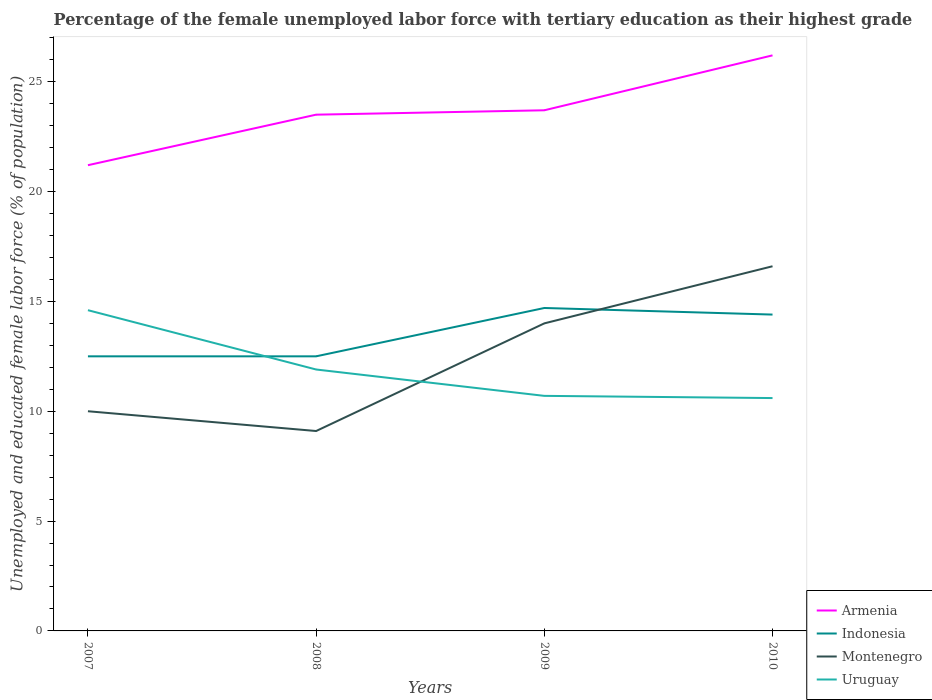Is the number of lines equal to the number of legend labels?
Ensure brevity in your answer.  Yes. Across all years, what is the maximum percentage of the unemployed female labor force with tertiary education in Montenegro?
Your answer should be compact. 9.1. In which year was the percentage of the unemployed female labor force with tertiary education in Montenegro maximum?
Provide a succinct answer. 2008. What is the total percentage of the unemployed female labor force with tertiary education in Uruguay in the graph?
Your response must be concise. 1.2. What is the difference between the highest and the second highest percentage of the unemployed female labor force with tertiary education in Indonesia?
Offer a very short reply. 2.2. What is the difference between the highest and the lowest percentage of the unemployed female labor force with tertiary education in Montenegro?
Ensure brevity in your answer.  2. Is the percentage of the unemployed female labor force with tertiary education in Montenegro strictly greater than the percentage of the unemployed female labor force with tertiary education in Indonesia over the years?
Give a very brief answer. No. What is the difference between two consecutive major ticks on the Y-axis?
Make the answer very short. 5. How many legend labels are there?
Offer a terse response. 4. How are the legend labels stacked?
Your answer should be compact. Vertical. What is the title of the graph?
Ensure brevity in your answer.  Percentage of the female unemployed labor force with tertiary education as their highest grade. What is the label or title of the X-axis?
Your response must be concise. Years. What is the label or title of the Y-axis?
Offer a terse response. Unemployed and educated female labor force (% of population). What is the Unemployed and educated female labor force (% of population) of Armenia in 2007?
Offer a very short reply. 21.2. What is the Unemployed and educated female labor force (% of population) of Indonesia in 2007?
Your answer should be compact. 12.5. What is the Unemployed and educated female labor force (% of population) in Uruguay in 2007?
Offer a very short reply. 14.6. What is the Unemployed and educated female labor force (% of population) of Indonesia in 2008?
Your answer should be very brief. 12.5. What is the Unemployed and educated female labor force (% of population) in Montenegro in 2008?
Provide a short and direct response. 9.1. What is the Unemployed and educated female labor force (% of population) of Uruguay in 2008?
Your response must be concise. 11.9. What is the Unemployed and educated female labor force (% of population) of Armenia in 2009?
Provide a succinct answer. 23.7. What is the Unemployed and educated female labor force (% of population) in Indonesia in 2009?
Give a very brief answer. 14.7. What is the Unemployed and educated female labor force (% of population) in Uruguay in 2009?
Provide a succinct answer. 10.7. What is the Unemployed and educated female labor force (% of population) of Armenia in 2010?
Your answer should be very brief. 26.2. What is the Unemployed and educated female labor force (% of population) of Indonesia in 2010?
Your response must be concise. 14.4. What is the Unemployed and educated female labor force (% of population) in Montenegro in 2010?
Keep it short and to the point. 16.6. What is the Unemployed and educated female labor force (% of population) in Uruguay in 2010?
Your response must be concise. 10.6. Across all years, what is the maximum Unemployed and educated female labor force (% of population) of Armenia?
Provide a short and direct response. 26.2. Across all years, what is the maximum Unemployed and educated female labor force (% of population) of Indonesia?
Provide a short and direct response. 14.7. Across all years, what is the maximum Unemployed and educated female labor force (% of population) of Montenegro?
Provide a short and direct response. 16.6. Across all years, what is the maximum Unemployed and educated female labor force (% of population) of Uruguay?
Offer a terse response. 14.6. Across all years, what is the minimum Unemployed and educated female labor force (% of population) in Armenia?
Offer a terse response. 21.2. Across all years, what is the minimum Unemployed and educated female labor force (% of population) of Indonesia?
Make the answer very short. 12.5. Across all years, what is the minimum Unemployed and educated female labor force (% of population) of Montenegro?
Offer a terse response. 9.1. Across all years, what is the minimum Unemployed and educated female labor force (% of population) of Uruguay?
Provide a succinct answer. 10.6. What is the total Unemployed and educated female labor force (% of population) of Armenia in the graph?
Make the answer very short. 94.6. What is the total Unemployed and educated female labor force (% of population) of Indonesia in the graph?
Make the answer very short. 54.1. What is the total Unemployed and educated female labor force (% of population) of Montenegro in the graph?
Provide a short and direct response. 49.7. What is the total Unemployed and educated female labor force (% of population) of Uruguay in the graph?
Offer a terse response. 47.8. What is the difference between the Unemployed and educated female labor force (% of population) in Armenia in 2007 and that in 2008?
Offer a terse response. -2.3. What is the difference between the Unemployed and educated female labor force (% of population) in Indonesia in 2007 and that in 2008?
Keep it short and to the point. 0. What is the difference between the Unemployed and educated female labor force (% of population) of Armenia in 2007 and that in 2009?
Your answer should be compact. -2.5. What is the difference between the Unemployed and educated female labor force (% of population) in Armenia in 2007 and that in 2010?
Offer a very short reply. -5. What is the difference between the Unemployed and educated female labor force (% of population) in Indonesia in 2007 and that in 2010?
Offer a very short reply. -1.9. What is the difference between the Unemployed and educated female labor force (% of population) in Montenegro in 2007 and that in 2010?
Ensure brevity in your answer.  -6.6. What is the difference between the Unemployed and educated female labor force (% of population) of Uruguay in 2007 and that in 2010?
Your answer should be compact. 4. What is the difference between the Unemployed and educated female labor force (% of population) of Montenegro in 2008 and that in 2009?
Provide a short and direct response. -4.9. What is the difference between the Unemployed and educated female labor force (% of population) of Armenia in 2008 and that in 2010?
Give a very brief answer. -2.7. What is the difference between the Unemployed and educated female labor force (% of population) of Indonesia in 2008 and that in 2010?
Provide a short and direct response. -1.9. What is the difference between the Unemployed and educated female labor force (% of population) of Armenia in 2007 and the Unemployed and educated female labor force (% of population) of Montenegro in 2008?
Your answer should be very brief. 12.1. What is the difference between the Unemployed and educated female labor force (% of population) of Indonesia in 2007 and the Unemployed and educated female labor force (% of population) of Montenegro in 2008?
Your answer should be very brief. 3.4. What is the difference between the Unemployed and educated female labor force (% of population) in Indonesia in 2007 and the Unemployed and educated female labor force (% of population) in Uruguay in 2008?
Your response must be concise. 0.6. What is the difference between the Unemployed and educated female labor force (% of population) of Armenia in 2007 and the Unemployed and educated female labor force (% of population) of Montenegro in 2009?
Your response must be concise. 7.2. What is the difference between the Unemployed and educated female labor force (% of population) in Armenia in 2007 and the Unemployed and educated female labor force (% of population) in Uruguay in 2009?
Give a very brief answer. 10.5. What is the difference between the Unemployed and educated female labor force (% of population) in Indonesia in 2007 and the Unemployed and educated female labor force (% of population) in Montenegro in 2009?
Offer a terse response. -1.5. What is the difference between the Unemployed and educated female labor force (% of population) of Indonesia in 2007 and the Unemployed and educated female labor force (% of population) of Uruguay in 2009?
Provide a short and direct response. 1.8. What is the difference between the Unemployed and educated female labor force (% of population) in Armenia in 2007 and the Unemployed and educated female labor force (% of population) in Uruguay in 2010?
Make the answer very short. 10.6. What is the difference between the Unemployed and educated female labor force (% of population) of Indonesia in 2007 and the Unemployed and educated female labor force (% of population) of Montenegro in 2010?
Give a very brief answer. -4.1. What is the difference between the Unemployed and educated female labor force (% of population) of Armenia in 2008 and the Unemployed and educated female labor force (% of population) of Indonesia in 2009?
Offer a very short reply. 8.8. What is the difference between the Unemployed and educated female labor force (% of population) of Armenia in 2008 and the Unemployed and educated female labor force (% of population) of Montenegro in 2009?
Your answer should be very brief. 9.5. What is the difference between the Unemployed and educated female labor force (% of population) in Armenia in 2008 and the Unemployed and educated female labor force (% of population) in Uruguay in 2009?
Provide a succinct answer. 12.8. What is the difference between the Unemployed and educated female labor force (% of population) in Indonesia in 2008 and the Unemployed and educated female labor force (% of population) in Montenegro in 2009?
Your answer should be very brief. -1.5. What is the difference between the Unemployed and educated female labor force (% of population) of Indonesia in 2008 and the Unemployed and educated female labor force (% of population) of Uruguay in 2009?
Provide a short and direct response. 1.8. What is the difference between the Unemployed and educated female labor force (% of population) in Montenegro in 2008 and the Unemployed and educated female labor force (% of population) in Uruguay in 2009?
Provide a short and direct response. -1.6. What is the difference between the Unemployed and educated female labor force (% of population) in Armenia in 2008 and the Unemployed and educated female labor force (% of population) in Indonesia in 2010?
Your answer should be compact. 9.1. What is the difference between the Unemployed and educated female labor force (% of population) of Armenia in 2008 and the Unemployed and educated female labor force (% of population) of Uruguay in 2010?
Provide a succinct answer. 12.9. What is the difference between the Unemployed and educated female labor force (% of population) of Indonesia in 2008 and the Unemployed and educated female labor force (% of population) of Montenegro in 2010?
Your answer should be very brief. -4.1. What is the difference between the Unemployed and educated female labor force (% of population) in Montenegro in 2008 and the Unemployed and educated female labor force (% of population) in Uruguay in 2010?
Keep it short and to the point. -1.5. What is the difference between the Unemployed and educated female labor force (% of population) in Armenia in 2009 and the Unemployed and educated female labor force (% of population) in Indonesia in 2010?
Provide a succinct answer. 9.3. What is the difference between the Unemployed and educated female labor force (% of population) of Indonesia in 2009 and the Unemployed and educated female labor force (% of population) of Uruguay in 2010?
Provide a short and direct response. 4.1. What is the average Unemployed and educated female labor force (% of population) in Armenia per year?
Ensure brevity in your answer.  23.65. What is the average Unemployed and educated female labor force (% of population) of Indonesia per year?
Ensure brevity in your answer.  13.53. What is the average Unemployed and educated female labor force (% of population) of Montenegro per year?
Give a very brief answer. 12.43. What is the average Unemployed and educated female labor force (% of population) of Uruguay per year?
Offer a very short reply. 11.95. In the year 2007, what is the difference between the Unemployed and educated female labor force (% of population) of Armenia and Unemployed and educated female labor force (% of population) of Montenegro?
Offer a very short reply. 11.2. In the year 2007, what is the difference between the Unemployed and educated female labor force (% of population) in Indonesia and Unemployed and educated female labor force (% of population) in Uruguay?
Make the answer very short. -2.1. In the year 2008, what is the difference between the Unemployed and educated female labor force (% of population) of Armenia and Unemployed and educated female labor force (% of population) of Indonesia?
Provide a succinct answer. 11. In the year 2008, what is the difference between the Unemployed and educated female labor force (% of population) in Armenia and Unemployed and educated female labor force (% of population) in Montenegro?
Ensure brevity in your answer.  14.4. In the year 2008, what is the difference between the Unemployed and educated female labor force (% of population) of Armenia and Unemployed and educated female labor force (% of population) of Uruguay?
Your answer should be compact. 11.6. In the year 2008, what is the difference between the Unemployed and educated female labor force (% of population) of Indonesia and Unemployed and educated female labor force (% of population) of Montenegro?
Make the answer very short. 3.4. In the year 2008, what is the difference between the Unemployed and educated female labor force (% of population) in Indonesia and Unemployed and educated female labor force (% of population) in Uruguay?
Keep it short and to the point. 0.6. In the year 2008, what is the difference between the Unemployed and educated female labor force (% of population) of Montenegro and Unemployed and educated female labor force (% of population) of Uruguay?
Your answer should be compact. -2.8. In the year 2010, what is the difference between the Unemployed and educated female labor force (% of population) of Armenia and Unemployed and educated female labor force (% of population) of Indonesia?
Provide a succinct answer. 11.8. In the year 2010, what is the difference between the Unemployed and educated female labor force (% of population) of Armenia and Unemployed and educated female labor force (% of population) of Uruguay?
Give a very brief answer. 15.6. In the year 2010, what is the difference between the Unemployed and educated female labor force (% of population) of Indonesia and Unemployed and educated female labor force (% of population) of Montenegro?
Your response must be concise. -2.2. In the year 2010, what is the difference between the Unemployed and educated female labor force (% of population) in Indonesia and Unemployed and educated female labor force (% of population) in Uruguay?
Offer a very short reply. 3.8. What is the ratio of the Unemployed and educated female labor force (% of population) of Armenia in 2007 to that in 2008?
Your answer should be compact. 0.9. What is the ratio of the Unemployed and educated female labor force (% of population) in Indonesia in 2007 to that in 2008?
Ensure brevity in your answer.  1. What is the ratio of the Unemployed and educated female labor force (% of population) in Montenegro in 2007 to that in 2008?
Ensure brevity in your answer.  1.1. What is the ratio of the Unemployed and educated female labor force (% of population) of Uruguay in 2007 to that in 2008?
Your answer should be compact. 1.23. What is the ratio of the Unemployed and educated female labor force (% of population) of Armenia in 2007 to that in 2009?
Offer a very short reply. 0.89. What is the ratio of the Unemployed and educated female labor force (% of population) in Indonesia in 2007 to that in 2009?
Provide a succinct answer. 0.85. What is the ratio of the Unemployed and educated female labor force (% of population) in Uruguay in 2007 to that in 2009?
Ensure brevity in your answer.  1.36. What is the ratio of the Unemployed and educated female labor force (% of population) in Armenia in 2007 to that in 2010?
Give a very brief answer. 0.81. What is the ratio of the Unemployed and educated female labor force (% of population) of Indonesia in 2007 to that in 2010?
Your answer should be compact. 0.87. What is the ratio of the Unemployed and educated female labor force (% of population) of Montenegro in 2007 to that in 2010?
Ensure brevity in your answer.  0.6. What is the ratio of the Unemployed and educated female labor force (% of population) of Uruguay in 2007 to that in 2010?
Make the answer very short. 1.38. What is the ratio of the Unemployed and educated female labor force (% of population) of Armenia in 2008 to that in 2009?
Provide a succinct answer. 0.99. What is the ratio of the Unemployed and educated female labor force (% of population) of Indonesia in 2008 to that in 2009?
Keep it short and to the point. 0.85. What is the ratio of the Unemployed and educated female labor force (% of population) of Montenegro in 2008 to that in 2009?
Your answer should be very brief. 0.65. What is the ratio of the Unemployed and educated female labor force (% of population) of Uruguay in 2008 to that in 2009?
Provide a short and direct response. 1.11. What is the ratio of the Unemployed and educated female labor force (% of population) of Armenia in 2008 to that in 2010?
Provide a succinct answer. 0.9. What is the ratio of the Unemployed and educated female labor force (% of population) in Indonesia in 2008 to that in 2010?
Give a very brief answer. 0.87. What is the ratio of the Unemployed and educated female labor force (% of population) of Montenegro in 2008 to that in 2010?
Provide a short and direct response. 0.55. What is the ratio of the Unemployed and educated female labor force (% of population) of Uruguay in 2008 to that in 2010?
Provide a succinct answer. 1.12. What is the ratio of the Unemployed and educated female labor force (% of population) in Armenia in 2009 to that in 2010?
Your response must be concise. 0.9. What is the ratio of the Unemployed and educated female labor force (% of population) in Indonesia in 2009 to that in 2010?
Give a very brief answer. 1.02. What is the ratio of the Unemployed and educated female labor force (% of population) in Montenegro in 2009 to that in 2010?
Your response must be concise. 0.84. What is the ratio of the Unemployed and educated female labor force (% of population) of Uruguay in 2009 to that in 2010?
Make the answer very short. 1.01. What is the difference between the highest and the second highest Unemployed and educated female labor force (% of population) of Indonesia?
Offer a very short reply. 0.3. What is the difference between the highest and the second highest Unemployed and educated female labor force (% of population) of Montenegro?
Offer a very short reply. 2.6. 